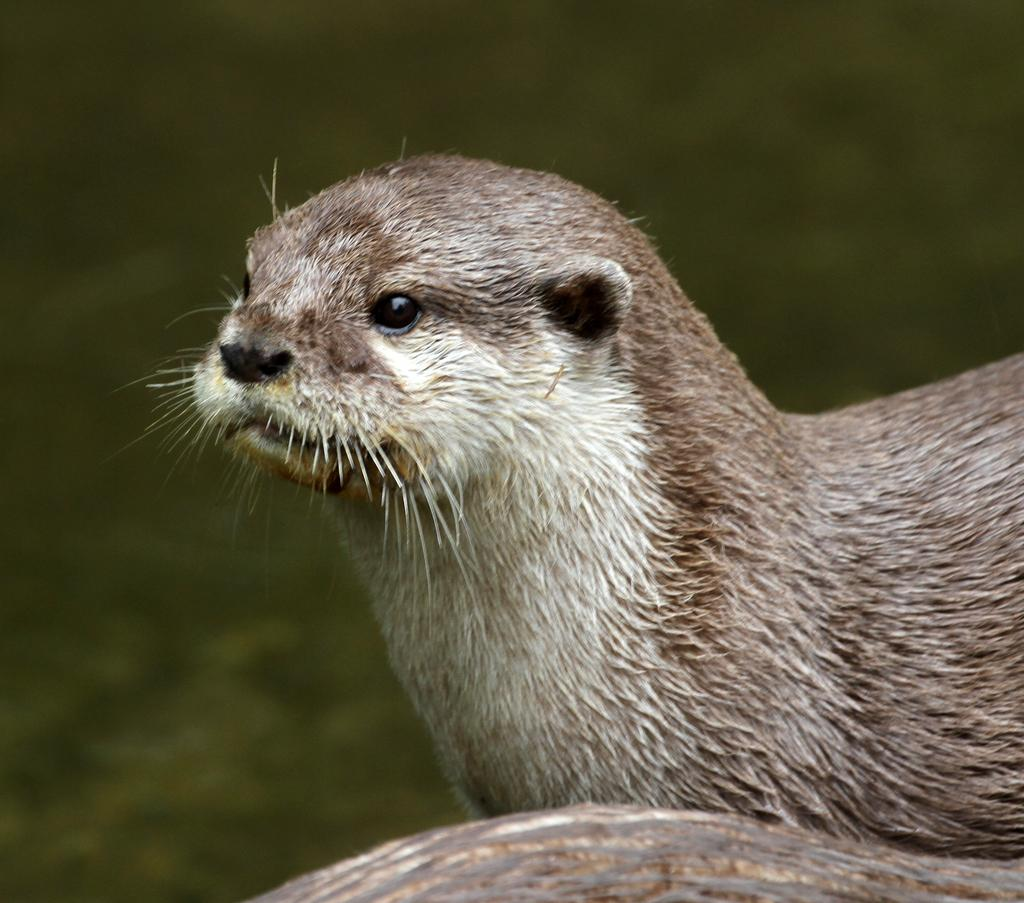What is the main subject of the image? There is an animal in the center of the image. What type of suit is the animal wearing in the image? There is no suit present in the image, as the main subject is an animal and animals do not wear suits. 